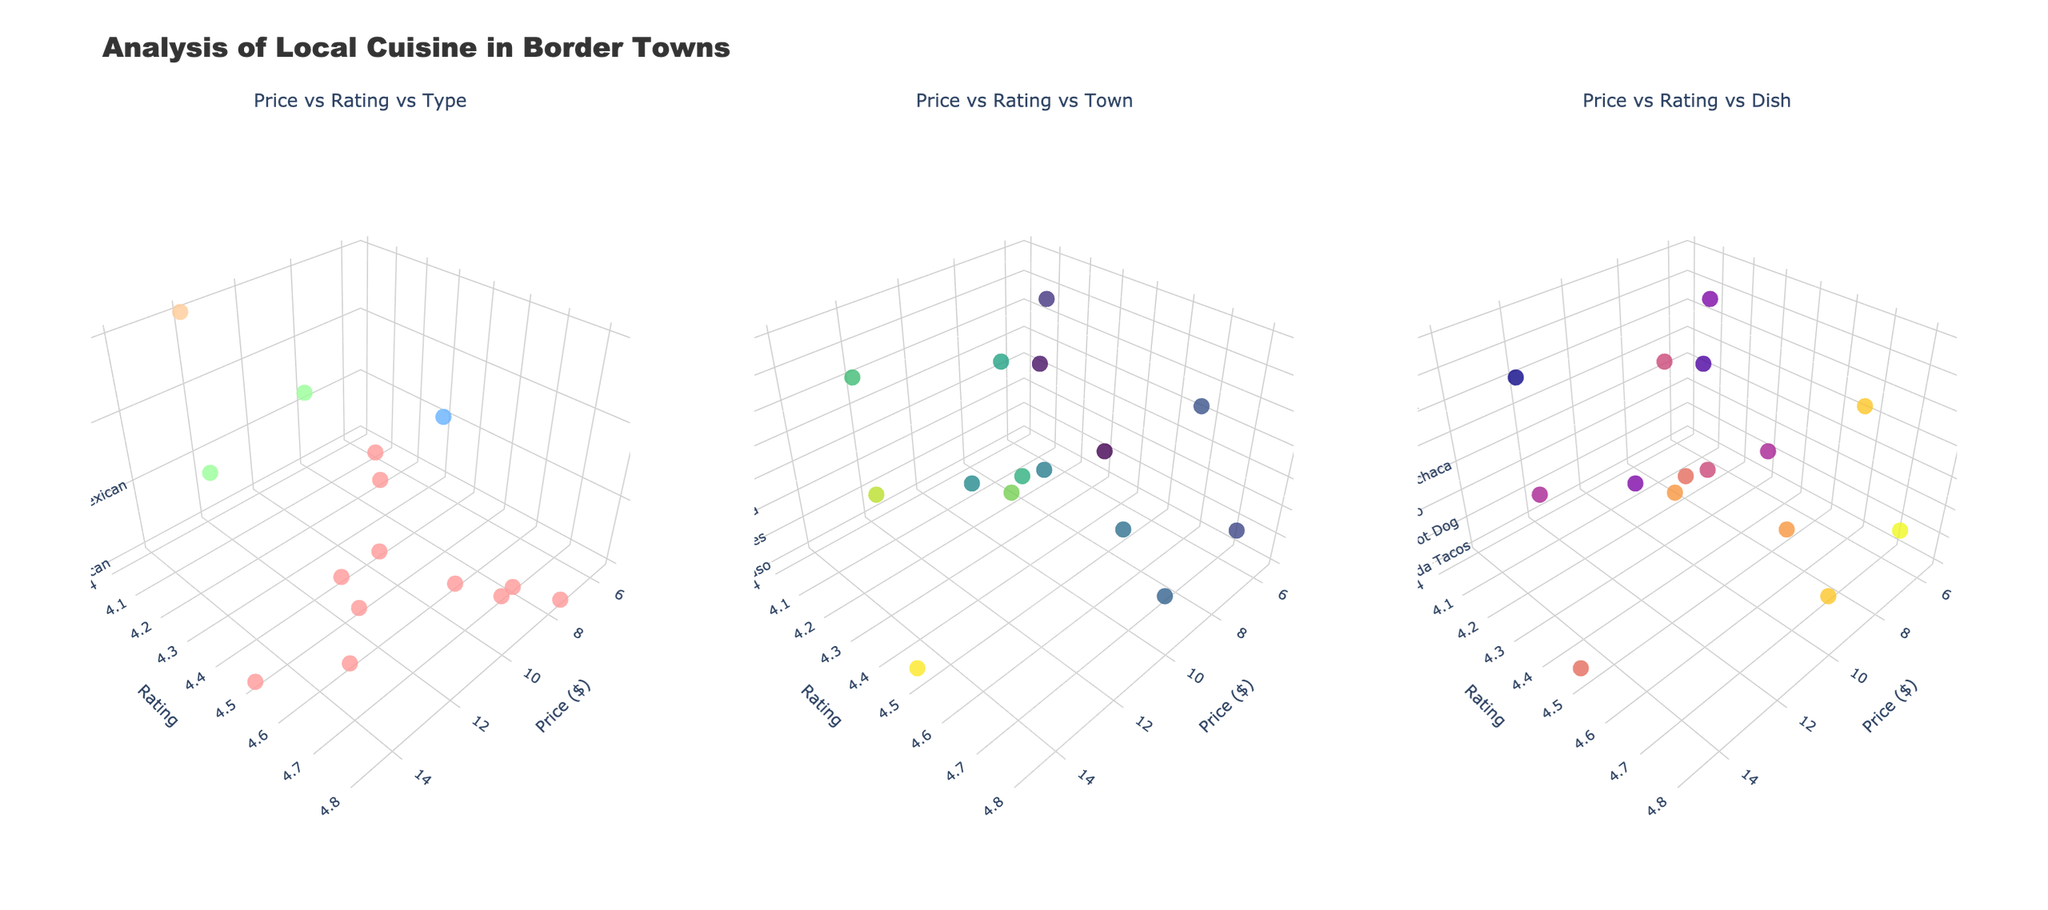What is the title of the plot? The title is prominently displayed at the top of the figure. It indicates the overall subject of the visualization.
Answer: Analysis of Local Cuisine in Border Towns How many subplots are there in the figure? You can see that the figure is divided into three sections, each showing a different aspect of the data.
Answer: 3 Can you identify the price range for Mexican dishes in the first subplot? Observing the scatterplot, you look for the markers colored specifically for Mexican dishes and find their placement on the x-axis, which represents the price.
Answer: $7.00 to $15.00 Which dish has the highest rating according to the third subplot? By examining the markers positioned on the y-axis (rating) and identifying the corresponding z-axis (dish) label, you find the highest data point.
Answer: Fish Tacos In the first subplot, which type of cuisine is represented by green-colored markers? The color used for Tex-Mex cuisine, as indicated in the code, is green (#99FF99). By looking at the subplot and identifying the green markers, you determine the type.
Answer: Tex-Mex What is the price and rating of the dish "Chiles en Nogada" shown in the second subplot? Locate the label for "Chiles en Nogada" by hovering over the markers and observe its position on the x-axis (price) and y-axis (rating).
Answer: $15.00 and 4.5 Compare the average price of Mexican dishes with Tex-Mex dishes. Which is higher? Calculate the average price of Mexican and Tex-Mex dishes from the data and compare the two values. Mexican dishes: (8.5 + 15 + 9 + 7.5 + 9.5 + 6 + 11 + 13 + 8 + 7 + 11)/11 = 9.95, Tex-Mex dishes: (10 + 14)/2 = 12.
Answer: Tex-Mex Which town has the highest concentration of highly-rated dishes (rating >= 4.5) in the second subplot? Identify the markers with a rating of 4.5 or above, then check the corresponding town each belongs to by examining the z-axis.
Answer: Juarez Is there any correlation between price and rating in the third subplot? By looking at the distribution of markers in the third subplot, you determine if higher prices tend to correspond to higher ratings or if they are randomly distributed.
Answer: No noticeable correlation Which town has the highest-rated Mexican dish in the figure? Identify the markers for Mexican dishes and note the town associated with the highest rating from the scatterplots.
Answer: San Diego 